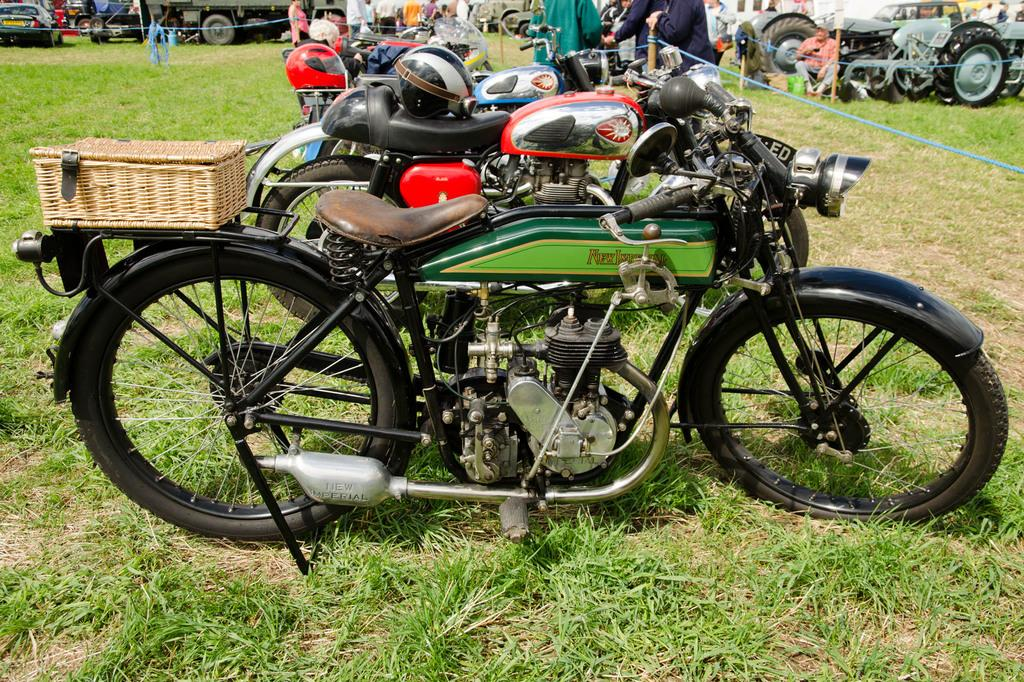What is happening on the grass in the image? There are vehicles on the grass in the image. Can you describe the people in the image? There is a group of people in the image. What is unique about the motorcycle on the left side of the image? There is a basket on a motorcycle on the left side of the image. Reasoning: Let's think step by step by step in order to produce the conversation. We start by identifying the main subjects and objects in the image based on the provided facts. We then formulate questions that focus on the location and characteristics of these subjects and objects, ensuring that each question can be answered definitively with the information given. We avoid yes/no questions and ensure that the language is simple and clear. Absurd Question/Answer: What type of dinner is being served on the grass in the image? There is no dinner being served in the image; it features vehicles on the grass and a group of people. How does the umbrella start the motorcycle in the image? There is no umbrella present in the image, and therefore it cannot start the motorcycle. How does the umbrella start the motorcycle in the image? There is no umbrella present in the image, and therefore it cannot start the motorcycle. 